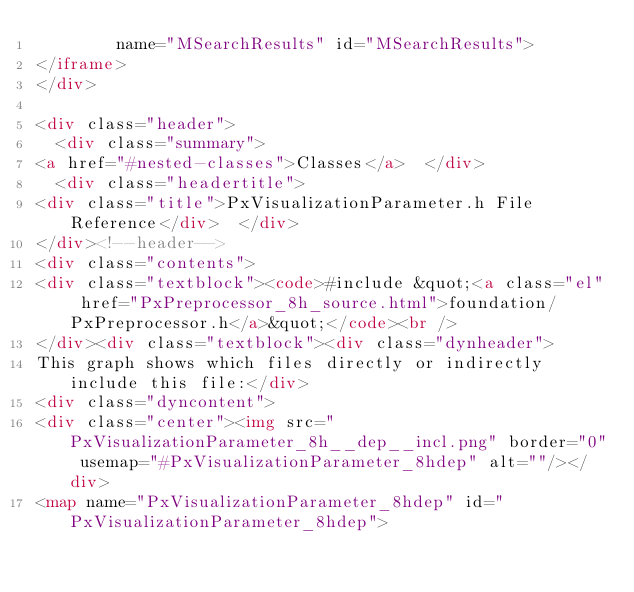<code> <loc_0><loc_0><loc_500><loc_500><_HTML_>        name="MSearchResults" id="MSearchResults">
</iframe>
</div>

<div class="header">
  <div class="summary">
<a href="#nested-classes">Classes</a>  </div>
  <div class="headertitle">
<div class="title">PxVisualizationParameter.h File Reference</div>  </div>
</div><!--header-->
<div class="contents">
<div class="textblock"><code>#include &quot;<a class="el" href="PxPreprocessor_8h_source.html">foundation/PxPreprocessor.h</a>&quot;</code><br />
</div><div class="textblock"><div class="dynheader">
This graph shows which files directly or indirectly include this file:</div>
<div class="dyncontent">
<div class="center"><img src="PxVisualizationParameter_8h__dep__incl.png" border="0" usemap="#PxVisualizationParameter_8hdep" alt=""/></div>
<map name="PxVisualizationParameter_8hdep" id="PxVisualizationParameter_8hdep"></code> 